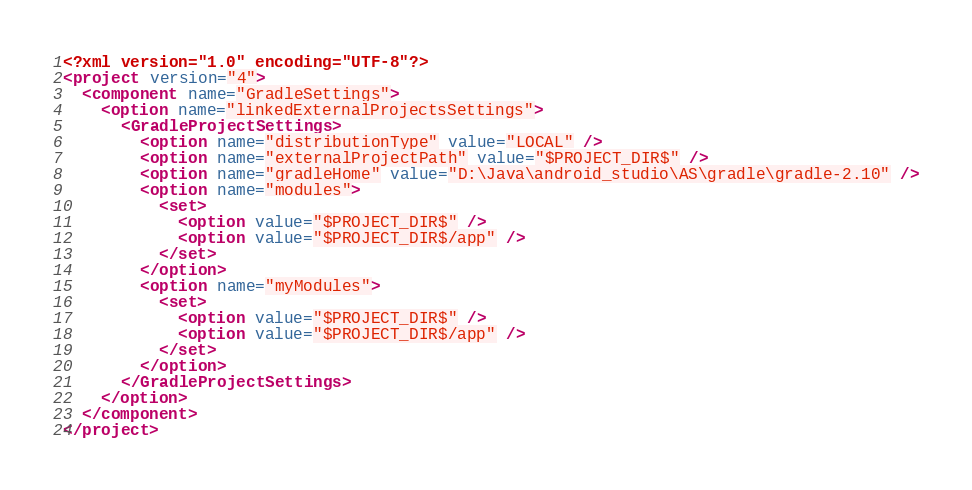Convert code to text. <code><loc_0><loc_0><loc_500><loc_500><_XML_><?xml version="1.0" encoding="UTF-8"?>
<project version="4">
  <component name="GradleSettings">
    <option name="linkedExternalProjectsSettings">
      <GradleProjectSettings>
        <option name="distributionType" value="LOCAL" />
        <option name="externalProjectPath" value="$PROJECT_DIR$" />
        <option name="gradleHome" value="D:\Java\android_studio\AS\gradle\gradle-2.10" />
        <option name="modules">
          <set>
            <option value="$PROJECT_DIR$" />
            <option value="$PROJECT_DIR$/app" />
          </set>
        </option>
        <option name="myModules">
          <set>
            <option value="$PROJECT_DIR$" />
            <option value="$PROJECT_DIR$/app" />
          </set>
        </option>
      </GradleProjectSettings>
    </option>
  </component>
</project></code> 